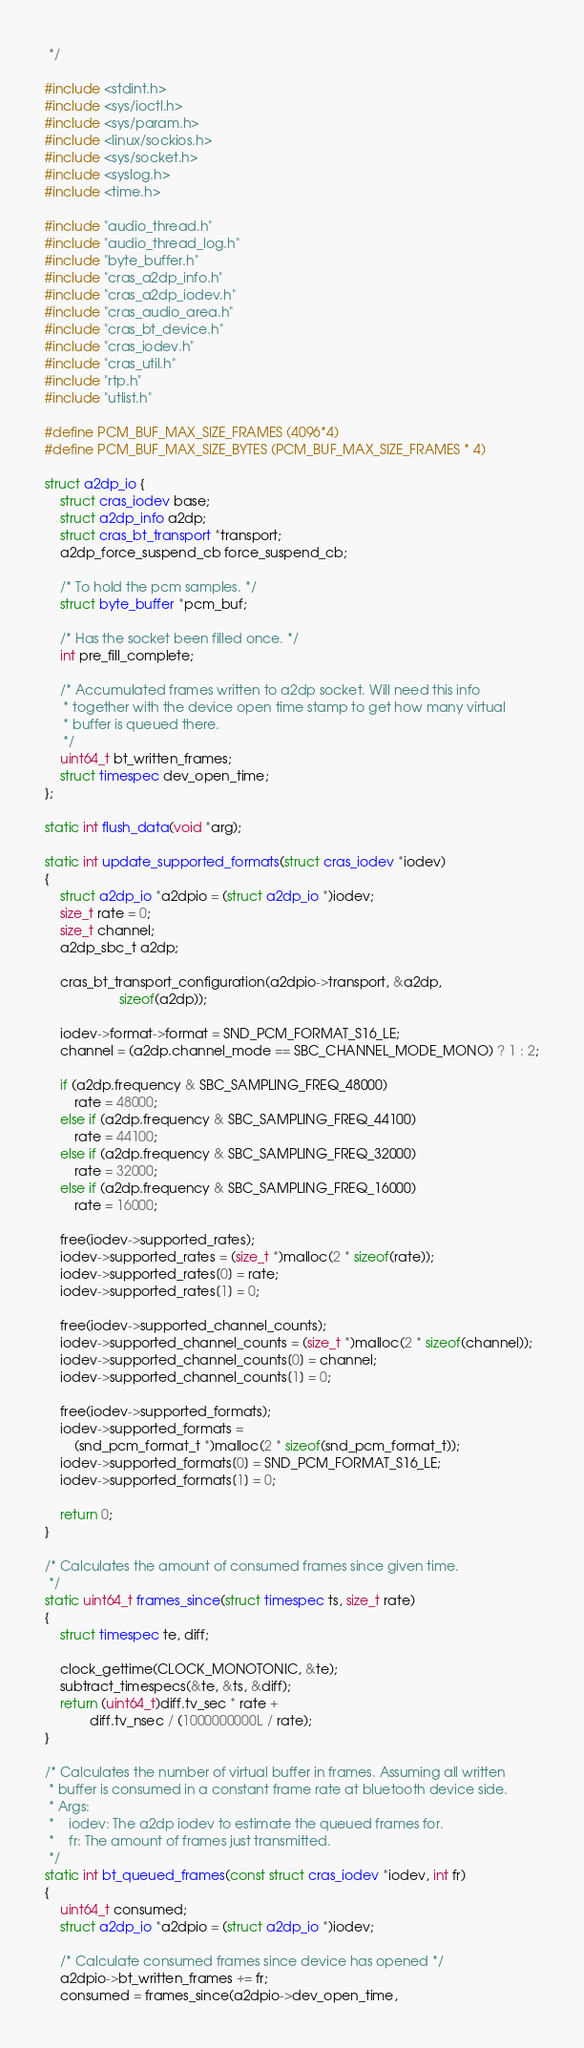Convert code to text. <code><loc_0><loc_0><loc_500><loc_500><_C_> */

#include <stdint.h>
#include <sys/ioctl.h>
#include <sys/param.h>
#include <linux/sockios.h>
#include <sys/socket.h>
#include <syslog.h>
#include <time.h>

#include "audio_thread.h"
#include "audio_thread_log.h"
#include "byte_buffer.h"
#include "cras_a2dp_info.h"
#include "cras_a2dp_iodev.h"
#include "cras_audio_area.h"
#include "cras_bt_device.h"
#include "cras_iodev.h"
#include "cras_util.h"
#include "rtp.h"
#include "utlist.h"

#define PCM_BUF_MAX_SIZE_FRAMES (4096*4)
#define PCM_BUF_MAX_SIZE_BYTES (PCM_BUF_MAX_SIZE_FRAMES * 4)

struct a2dp_io {
	struct cras_iodev base;
	struct a2dp_info a2dp;
	struct cras_bt_transport *transport;
	a2dp_force_suspend_cb force_suspend_cb;

	/* To hold the pcm samples. */
	struct byte_buffer *pcm_buf;

	/* Has the socket been filled once. */
	int pre_fill_complete;

	/* Accumulated frames written to a2dp socket. Will need this info
	 * together with the device open time stamp to get how many virtual
	 * buffer is queued there.
	 */
	uint64_t bt_written_frames;
	struct timespec dev_open_time;
};

static int flush_data(void *arg);

static int update_supported_formats(struct cras_iodev *iodev)
{
	struct a2dp_io *a2dpio = (struct a2dp_io *)iodev;
	size_t rate = 0;
	size_t channel;
	a2dp_sbc_t a2dp;

	cras_bt_transport_configuration(a2dpio->transport, &a2dp,
					sizeof(a2dp));

	iodev->format->format = SND_PCM_FORMAT_S16_LE;
	channel = (a2dp.channel_mode == SBC_CHANNEL_MODE_MONO) ? 1 : 2;

	if (a2dp.frequency & SBC_SAMPLING_FREQ_48000)
		rate = 48000;
	else if (a2dp.frequency & SBC_SAMPLING_FREQ_44100)
		rate = 44100;
	else if (a2dp.frequency & SBC_SAMPLING_FREQ_32000)
		rate = 32000;
	else if (a2dp.frequency & SBC_SAMPLING_FREQ_16000)
		rate = 16000;

	free(iodev->supported_rates);
	iodev->supported_rates = (size_t *)malloc(2 * sizeof(rate));
	iodev->supported_rates[0] = rate;
	iodev->supported_rates[1] = 0;

	free(iodev->supported_channel_counts);
	iodev->supported_channel_counts = (size_t *)malloc(2 * sizeof(channel));
	iodev->supported_channel_counts[0] = channel;
	iodev->supported_channel_counts[1] = 0;

	free(iodev->supported_formats);
	iodev->supported_formats =
		(snd_pcm_format_t *)malloc(2 * sizeof(snd_pcm_format_t));
	iodev->supported_formats[0] = SND_PCM_FORMAT_S16_LE;
	iodev->supported_formats[1] = 0;

	return 0;
}

/* Calculates the amount of consumed frames since given time.
 */
static uint64_t frames_since(struct timespec ts, size_t rate)
{
	struct timespec te, diff;

	clock_gettime(CLOCK_MONOTONIC, &te);
	subtract_timespecs(&te, &ts, &diff);
	return (uint64_t)diff.tv_sec * rate +
			diff.tv_nsec / (1000000000L / rate);
}

/* Calculates the number of virtual buffer in frames. Assuming all written
 * buffer is consumed in a constant frame rate at bluetooth device side.
 * Args:
 *    iodev: The a2dp iodev to estimate the queued frames for.
 *    fr: The amount of frames just transmitted.
 */
static int bt_queued_frames(const struct cras_iodev *iodev, int fr)
{
	uint64_t consumed;
	struct a2dp_io *a2dpio = (struct a2dp_io *)iodev;

	/* Calculate consumed frames since device has opened */
	a2dpio->bt_written_frames += fr;
	consumed = frames_since(a2dpio->dev_open_time,</code> 